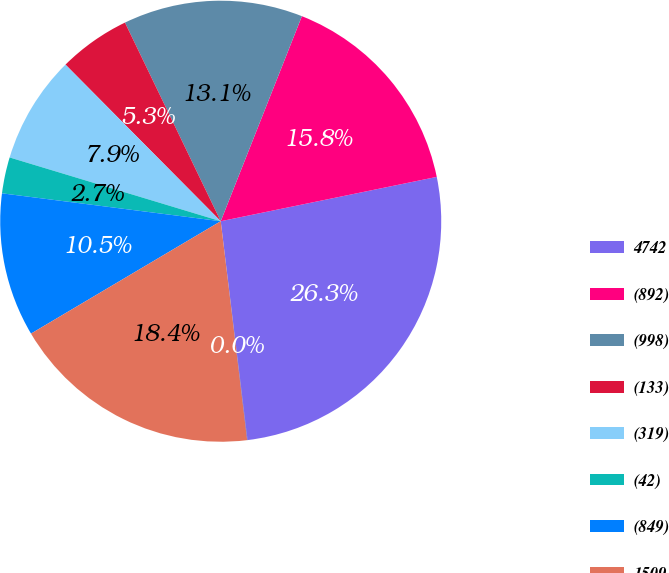Convert chart. <chart><loc_0><loc_0><loc_500><loc_500><pie_chart><fcel>4742<fcel>(892)<fcel>(998)<fcel>(133)<fcel>(319)<fcel>(42)<fcel>(849)<fcel>1509<fcel>611<nl><fcel>26.28%<fcel>15.78%<fcel>13.15%<fcel>5.28%<fcel>7.9%<fcel>2.65%<fcel>10.53%<fcel>18.4%<fcel>0.03%<nl></chart> 